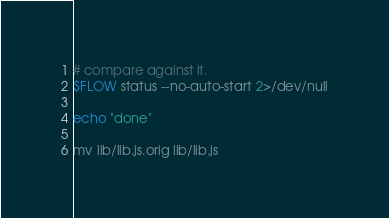<code> <loc_0><loc_0><loc_500><loc_500><_Bash_># compare against it.
$FLOW status --no-auto-start 2>/dev/null

echo "done"

mv lib/lib.js.orig lib/lib.js
</code> 